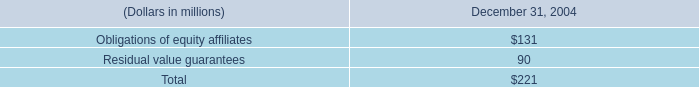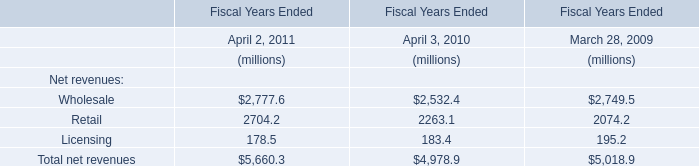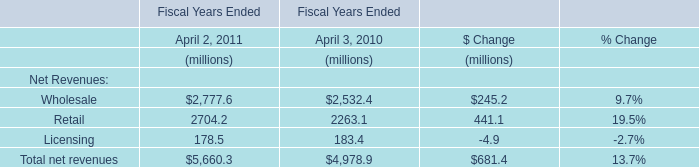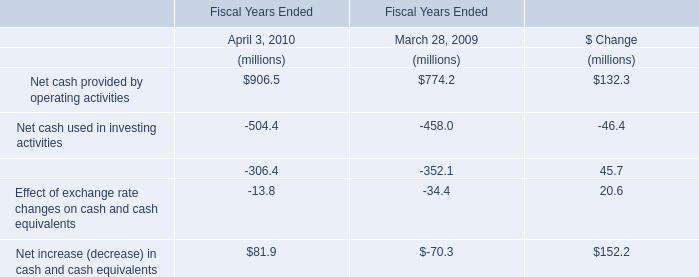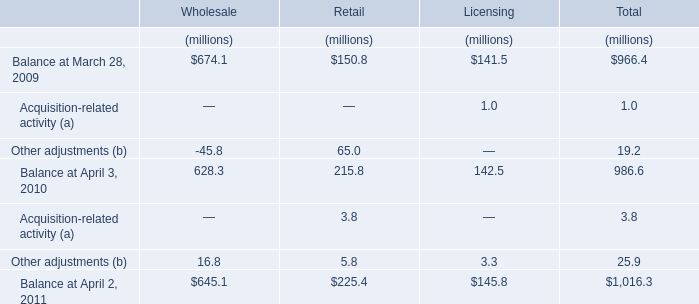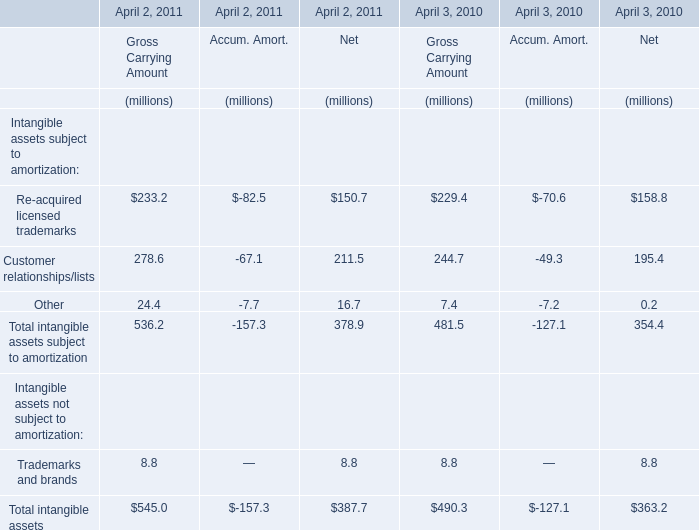In which year is Other adjustments greater than 60 ? 
Answer: 2009 in Retail. 